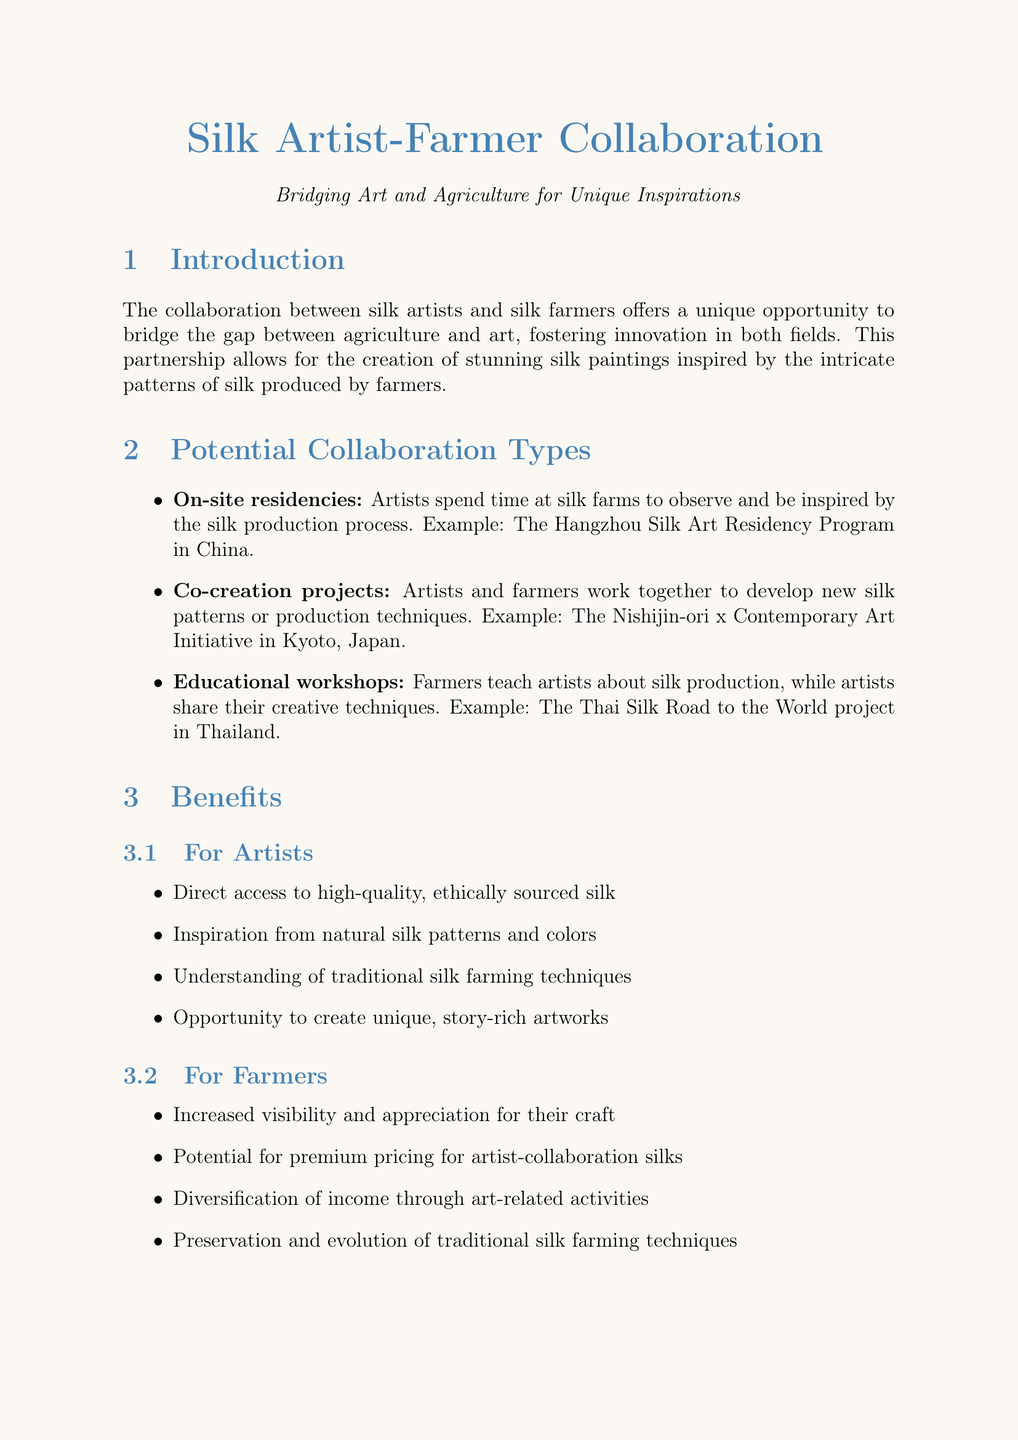what is the primary concept of collaboration in this document? The primary concept is the collaboration between silk artists and silk farmers for unique artistic inspirations.
Answer: collaboration between silk artists and silk farmers for unique artistic inspirations what is one potential collaboration type mentioned? The document lists various potential collaboration types, including on-site residencies.
Answer: On-site residencies what is an example of an educational workshop project? The document provides an example of an educational workshop project called the Thai Silk Road to the World.
Answer: The Thai Silk Road to the World what is one benefit for farmers from collaboration? One benefit for farmers is increased visibility and appreciation for their craft.
Answer: increased visibility and appreciation for their craft how many case studies are presented in the document? The number of case studies presented in the document is two.
Answer: two which funding opportunity focuses on sustainable urban development? The funding opportunity that focuses on sustainable urban development is the UNESCO Creative Cities Network.
Answer: UNESCO Creative Cities Network what is a challenge mentioned regarding artist-farmer collaboration? A challenge mentioned is language and cultural barriers between artists and farmers.
Answer: language and cultural barriers what future prospect involves technology integration? The future prospect that involves technology integration is the integration of technology in silk production for artistic purposes.
Answer: integration of technology in silk production for artistic purposes what is the conclusion's call to action? The conclusion's call to action encourages artists to seek out partnerships with silk farmers.
Answer: encourage artists to seek out partnerships with silk farmers 